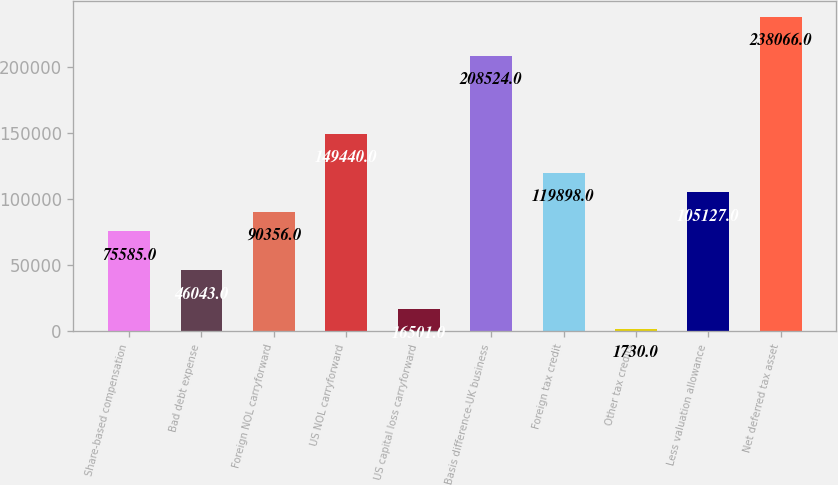Convert chart to OTSL. <chart><loc_0><loc_0><loc_500><loc_500><bar_chart><fcel>Share-based compensation<fcel>Bad debt expense<fcel>Foreign NOL carryforward<fcel>US NOL carryforward<fcel>US capital loss carryforward<fcel>Basis difference-UK business<fcel>Foreign tax credit<fcel>Other tax credits<fcel>Less valuation allowance<fcel>Net deferred tax asset<nl><fcel>75585<fcel>46043<fcel>90356<fcel>149440<fcel>16501<fcel>208524<fcel>119898<fcel>1730<fcel>105127<fcel>238066<nl></chart> 